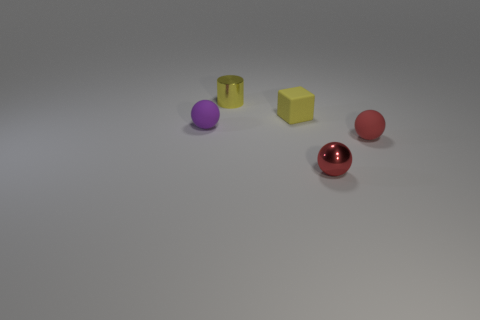Subtract all small purple rubber balls. How many balls are left? 2 Add 2 tiny purple balls. How many objects exist? 7 Subtract 1 balls. How many balls are left? 2 Subtract all purple spheres. How many spheres are left? 2 Add 4 small purple rubber things. How many small purple rubber things are left? 5 Add 4 tiny green cubes. How many tiny green cubes exist? 4 Subtract 1 purple balls. How many objects are left? 4 Subtract all cubes. How many objects are left? 4 Subtract all green spheres. Subtract all cyan cylinders. How many spheres are left? 3 Subtract all cyan cylinders. How many purple balls are left? 1 